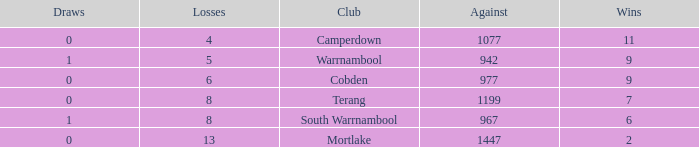What is the draw when the losses were more than 8 and less than 2 wins? None. 